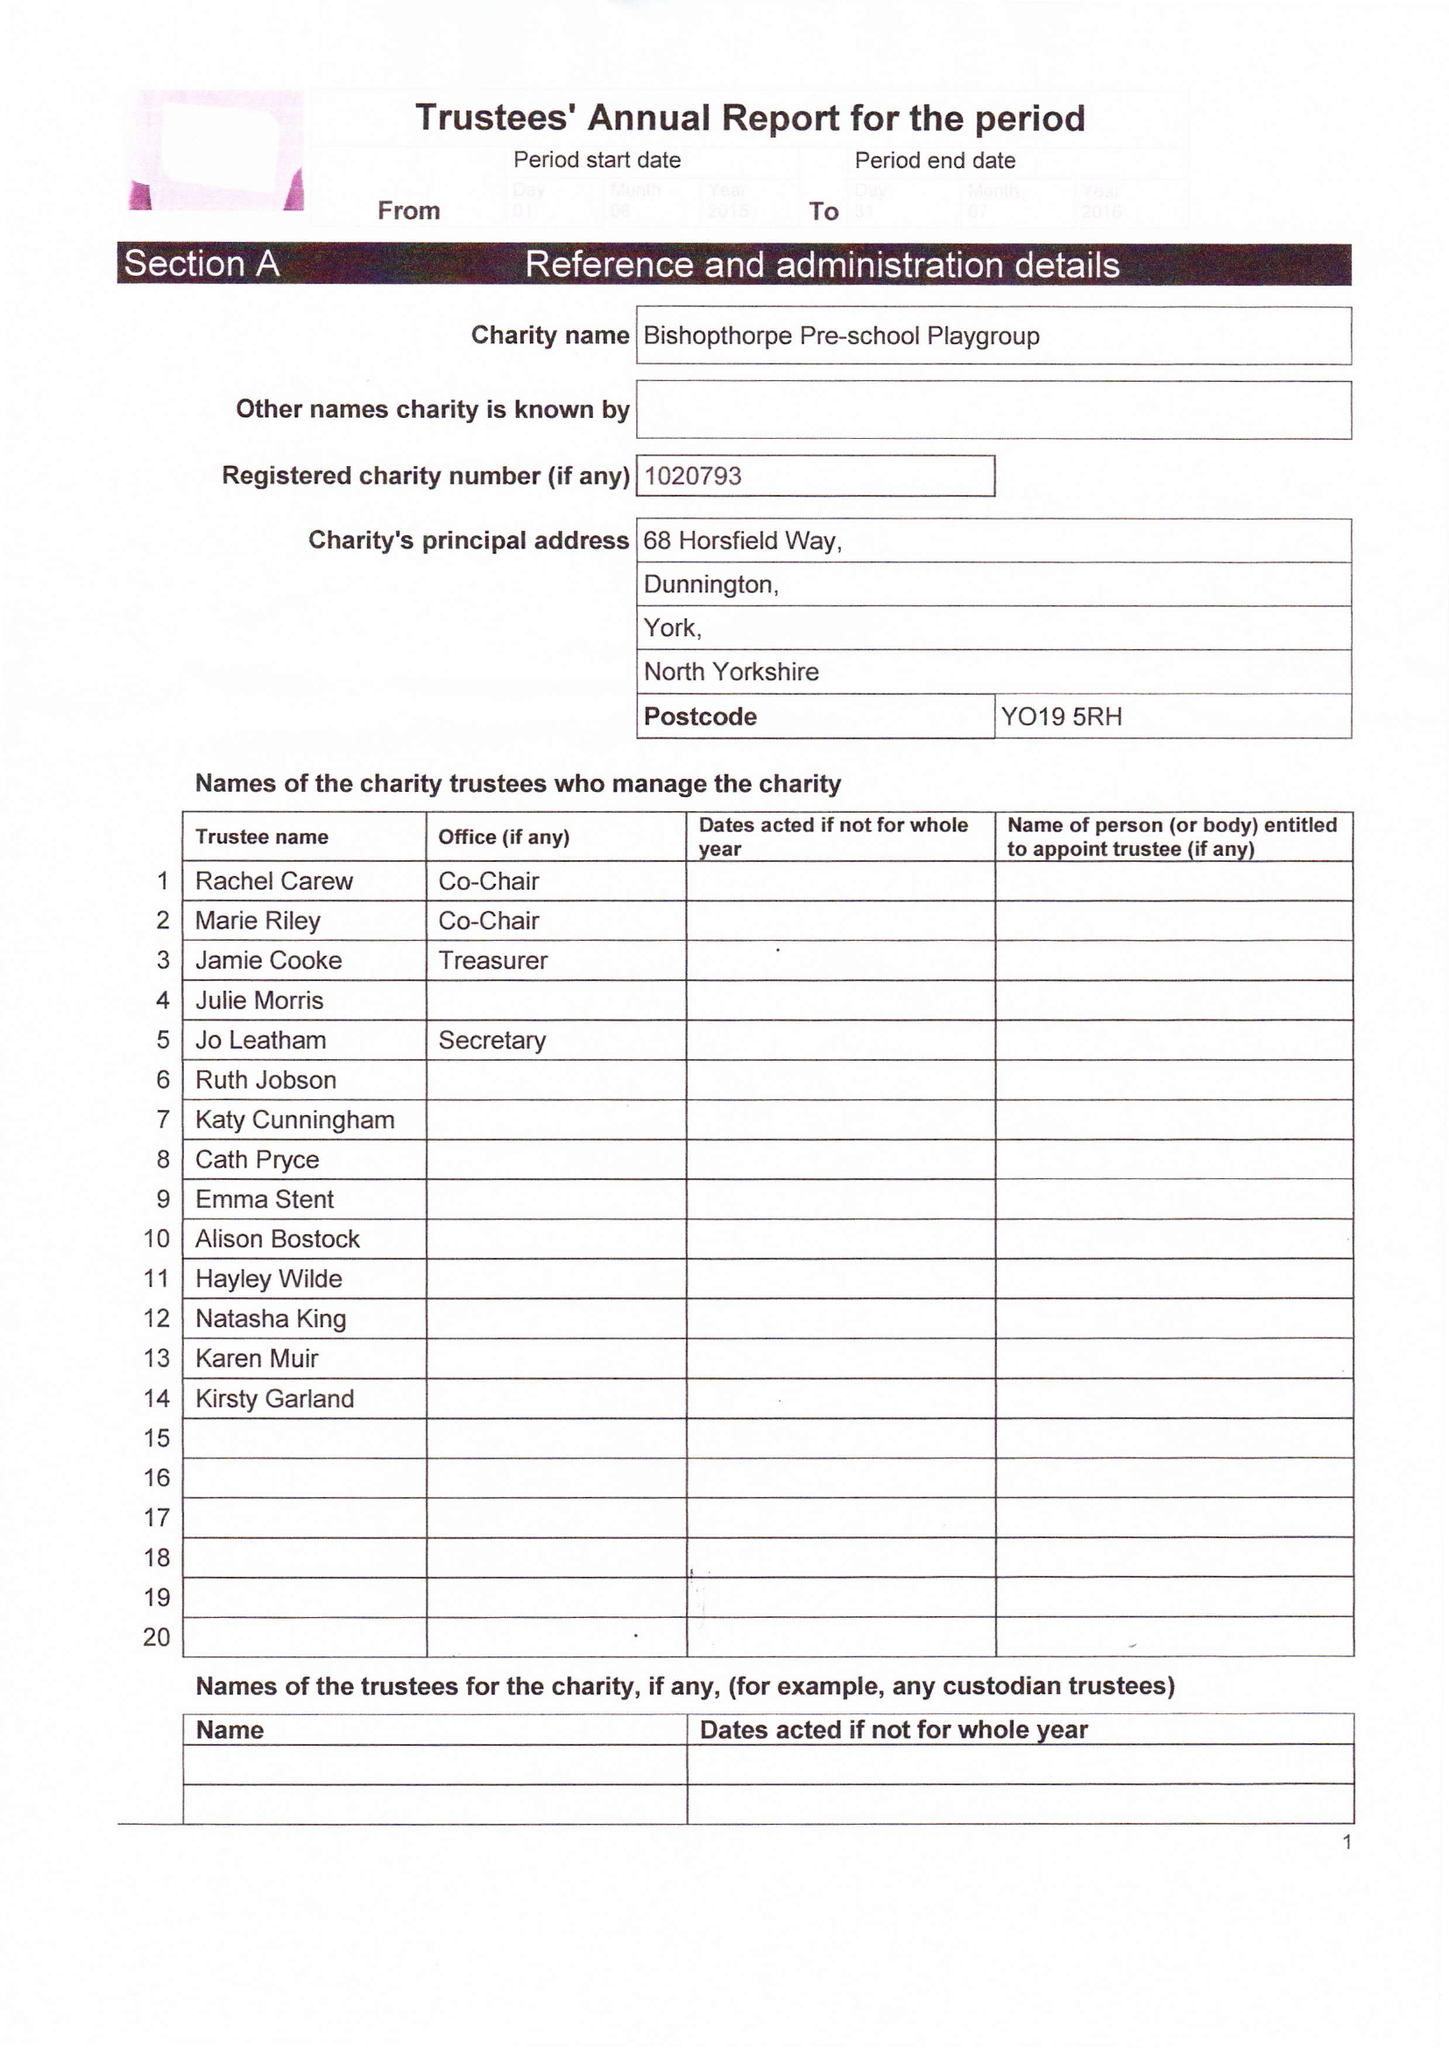What is the value for the address__post_town?
Answer the question using a single word or phrase. YORK 